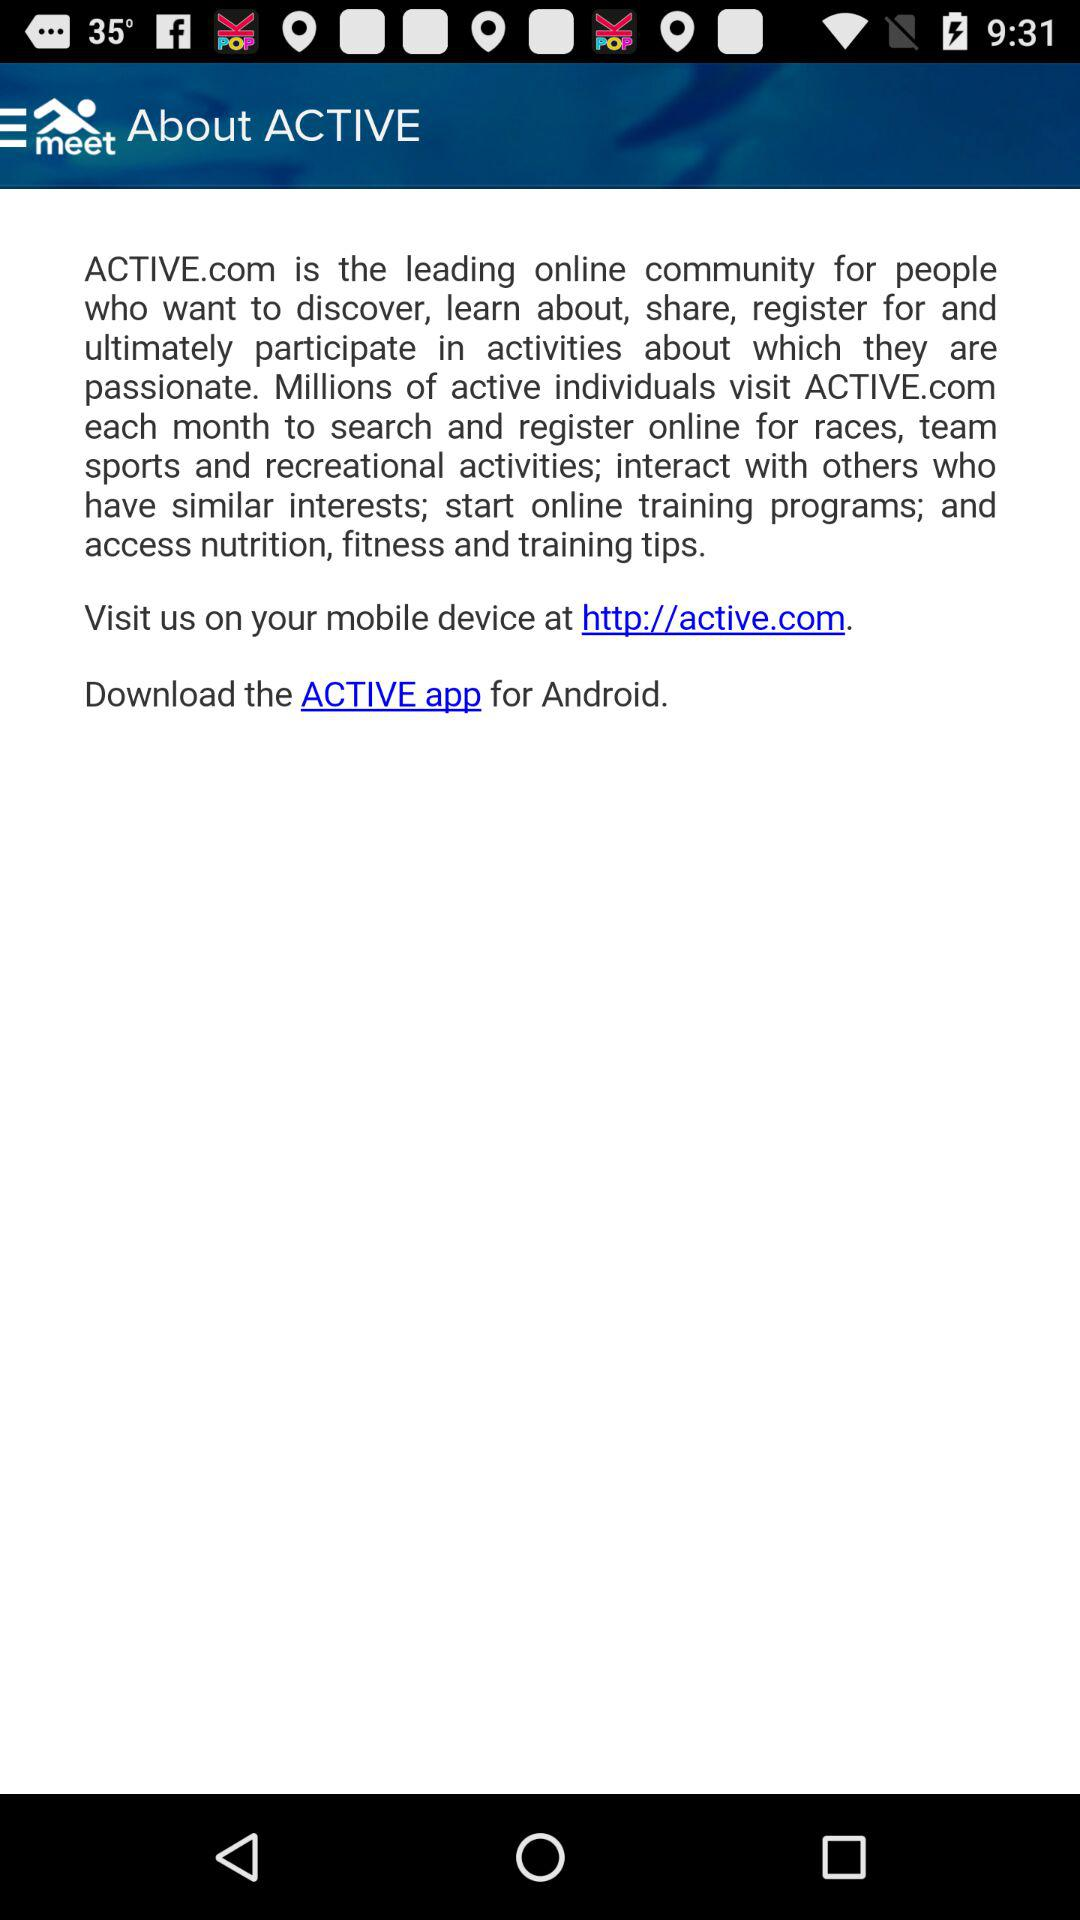What is the app name? The app names are "Meet Mobile" and "ACTIVE". 